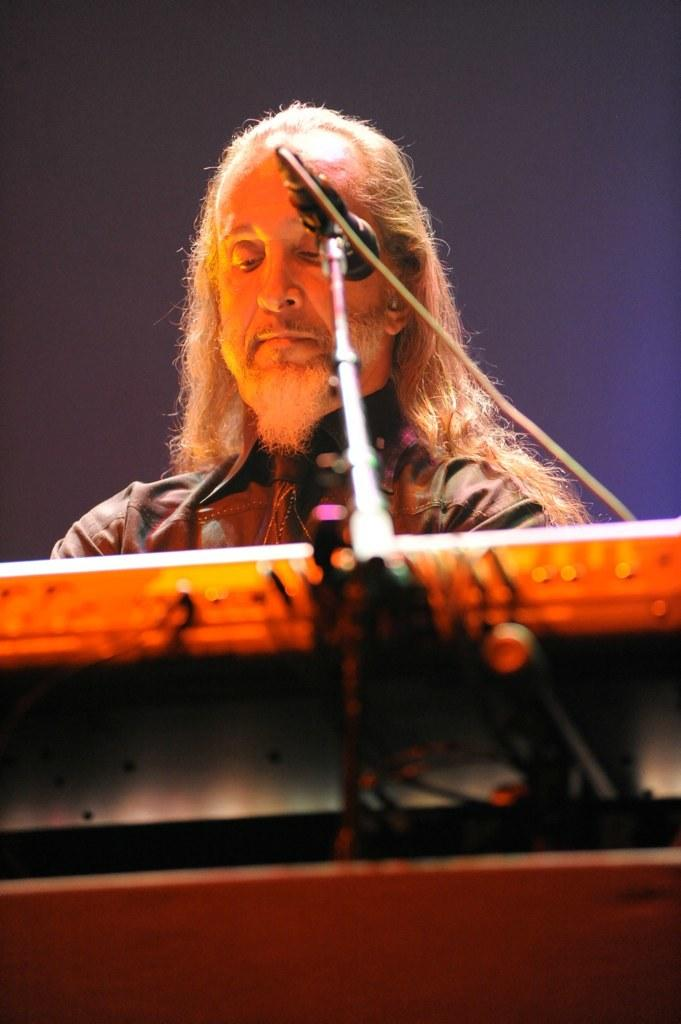Who is the main subject in the image? There is a man in the center of the image. What is the man holding in front of him? There is a microphone in front of the man. What other musical instrument is visible in the image? There is a musical keyboard in front of the man. What type of toothpaste is the man using in the image? There is no toothpaste present in the image. How does the man use the skate in the image? There is no skate present in the image. 